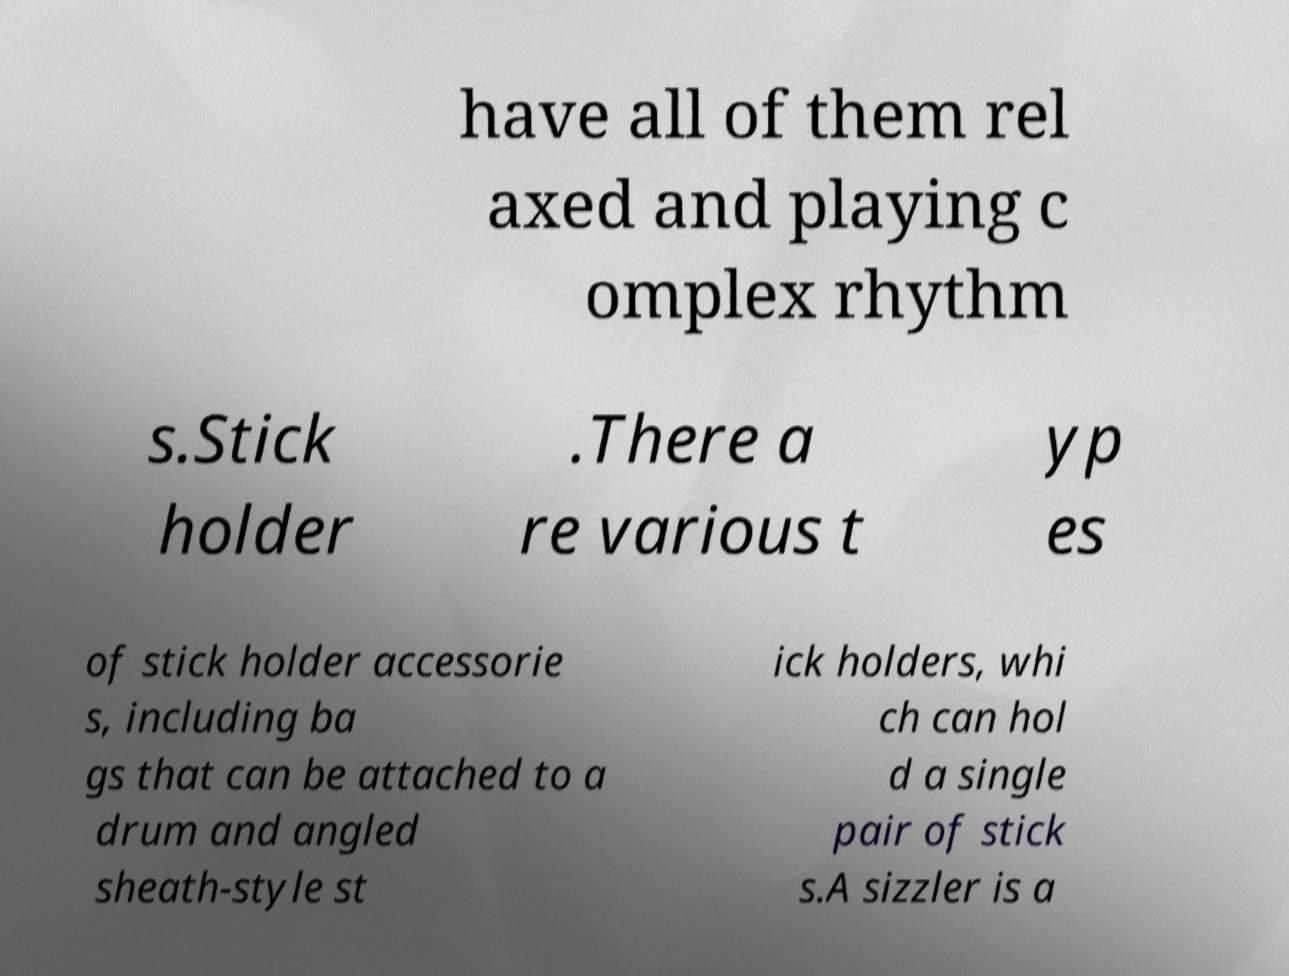I need the written content from this picture converted into text. Can you do that? have all of them rel axed and playing c omplex rhythm s.Stick holder .There a re various t yp es of stick holder accessorie s, including ba gs that can be attached to a drum and angled sheath-style st ick holders, whi ch can hol d a single pair of stick s.A sizzler is a 